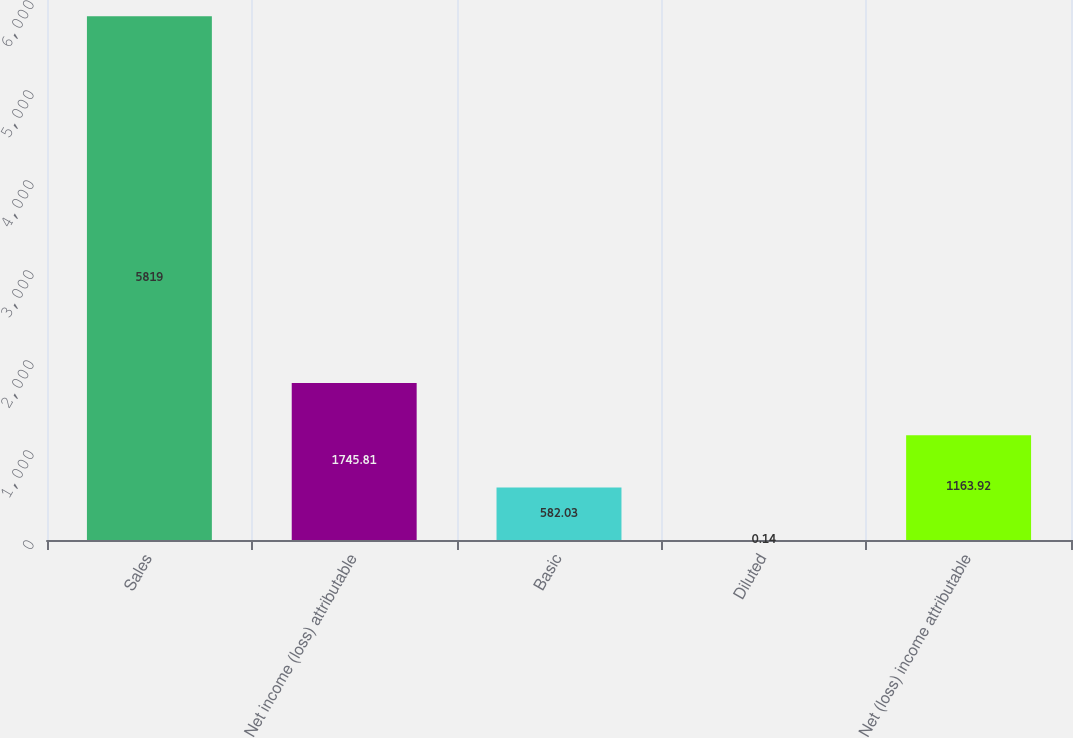Convert chart to OTSL. <chart><loc_0><loc_0><loc_500><loc_500><bar_chart><fcel>Sales<fcel>Net income (loss) attributable<fcel>Basic<fcel>Diluted<fcel>Net (loss) income attributable<nl><fcel>5819<fcel>1745.81<fcel>582.03<fcel>0.14<fcel>1163.92<nl></chart> 